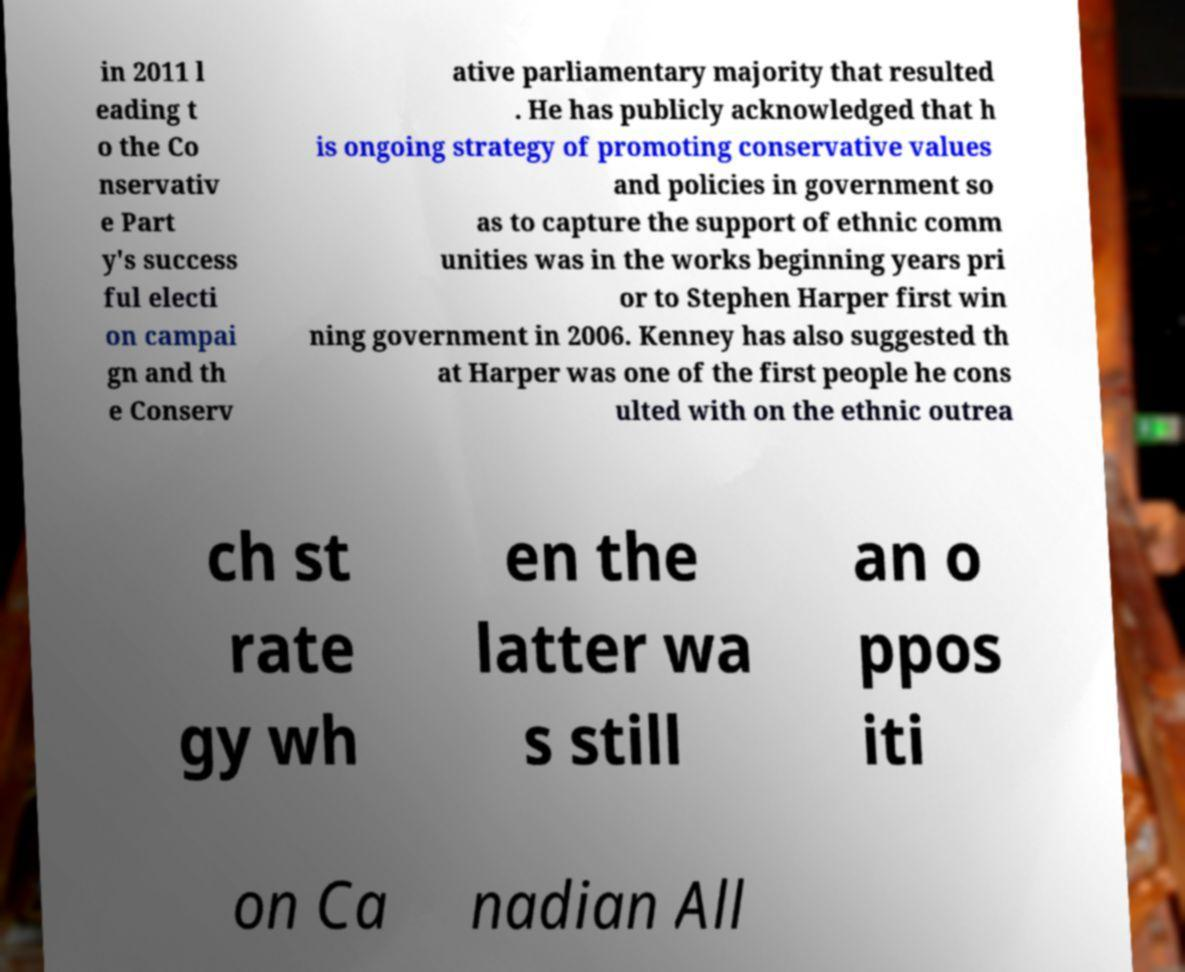Could you extract and type out the text from this image? in 2011 l eading t o the Co nservativ e Part y's success ful electi on campai gn and th e Conserv ative parliamentary majority that resulted . He has publicly acknowledged that h is ongoing strategy of promoting conservative values and policies in government so as to capture the support of ethnic comm unities was in the works beginning years pri or to Stephen Harper first win ning government in 2006. Kenney has also suggested th at Harper was one of the first people he cons ulted with on the ethnic outrea ch st rate gy wh en the latter wa s still an o ppos iti on Ca nadian All 